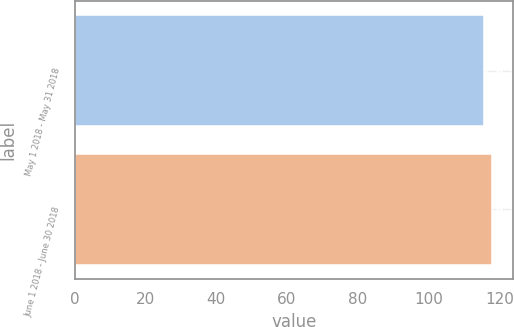Convert chart to OTSL. <chart><loc_0><loc_0><loc_500><loc_500><bar_chart><fcel>May 1 2018 - May 31 2018<fcel>June 1 2018 - June 30 2018<nl><fcel>115.73<fcel>118.04<nl></chart> 